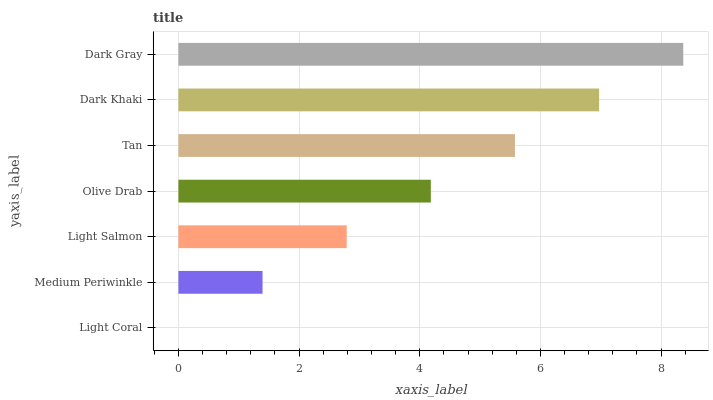Is Light Coral the minimum?
Answer yes or no. Yes. Is Dark Gray the maximum?
Answer yes or no. Yes. Is Medium Periwinkle the minimum?
Answer yes or no. No. Is Medium Periwinkle the maximum?
Answer yes or no. No. Is Medium Periwinkle greater than Light Coral?
Answer yes or no. Yes. Is Light Coral less than Medium Periwinkle?
Answer yes or no. Yes. Is Light Coral greater than Medium Periwinkle?
Answer yes or no. No. Is Medium Periwinkle less than Light Coral?
Answer yes or no. No. Is Olive Drab the high median?
Answer yes or no. Yes. Is Olive Drab the low median?
Answer yes or no. Yes. Is Dark Gray the high median?
Answer yes or no. No. Is Tan the low median?
Answer yes or no. No. 